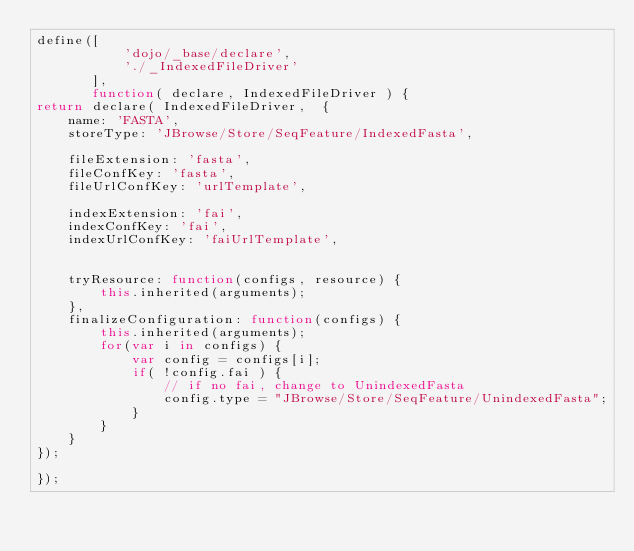<code> <loc_0><loc_0><loc_500><loc_500><_JavaScript_>define([
           'dojo/_base/declare',
           './_IndexedFileDriver'
       ],
       function( declare, IndexedFileDriver ) {
return declare( IndexedFileDriver,  {
    name: 'FASTA',
    storeType: 'JBrowse/Store/SeqFeature/IndexedFasta',

    fileExtension: 'fasta',
    fileConfKey: 'fasta',
    fileUrlConfKey: 'urlTemplate',

    indexExtension: 'fai',
    indexConfKey: 'fai',
    indexUrlConfKey: 'faiUrlTemplate',


    tryResource: function(configs, resource) {
        this.inherited(arguments);
    },
    finalizeConfiguration: function(configs) {
        this.inherited(arguments);
        for(var i in configs) {
            var config = configs[i];
            if( !config.fai ) {
                // if no fai, change to UnindexedFasta
                config.type = "JBrowse/Store/SeqFeature/UnindexedFasta";
            }
        }
    }
});

});
</code> 